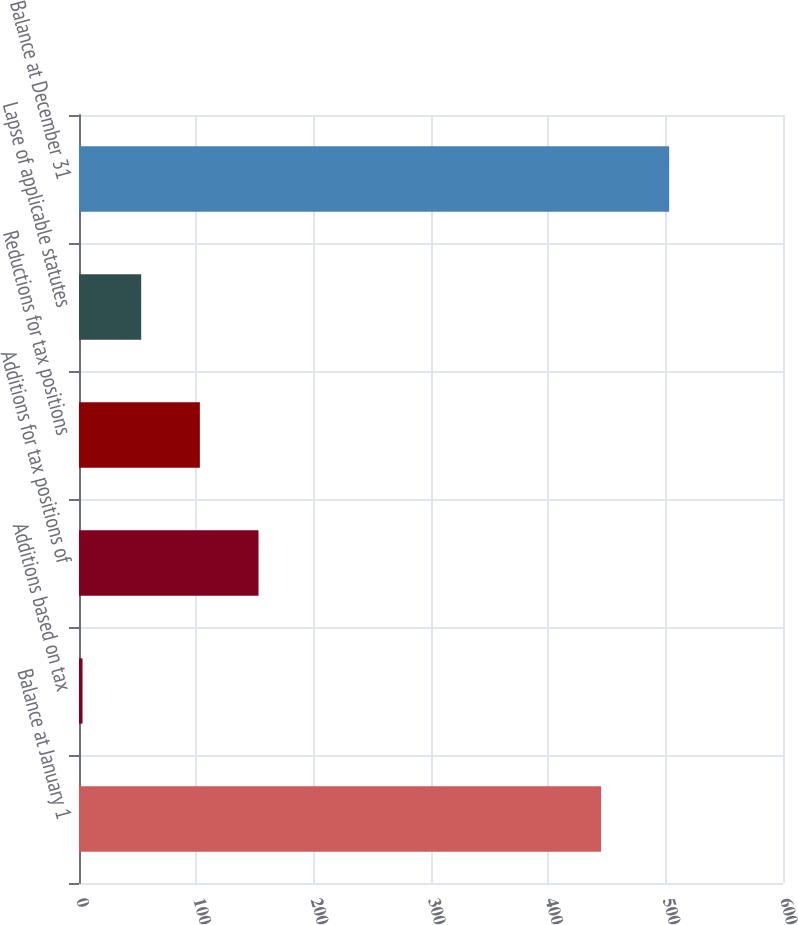Convert chart to OTSL. <chart><loc_0><loc_0><loc_500><loc_500><bar_chart><fcel>Balance at January 1<fcel>Additions based on tax<fcel>Additions for tax positions of<fcel>Reductions for tax positions<fcel>Lapse of applicable statutes<fcel>Balance at December 31<nl><fcel>445<fcel>3<fcel>153<fcel>103<fcel>53<fcel>503<nl></chart> 